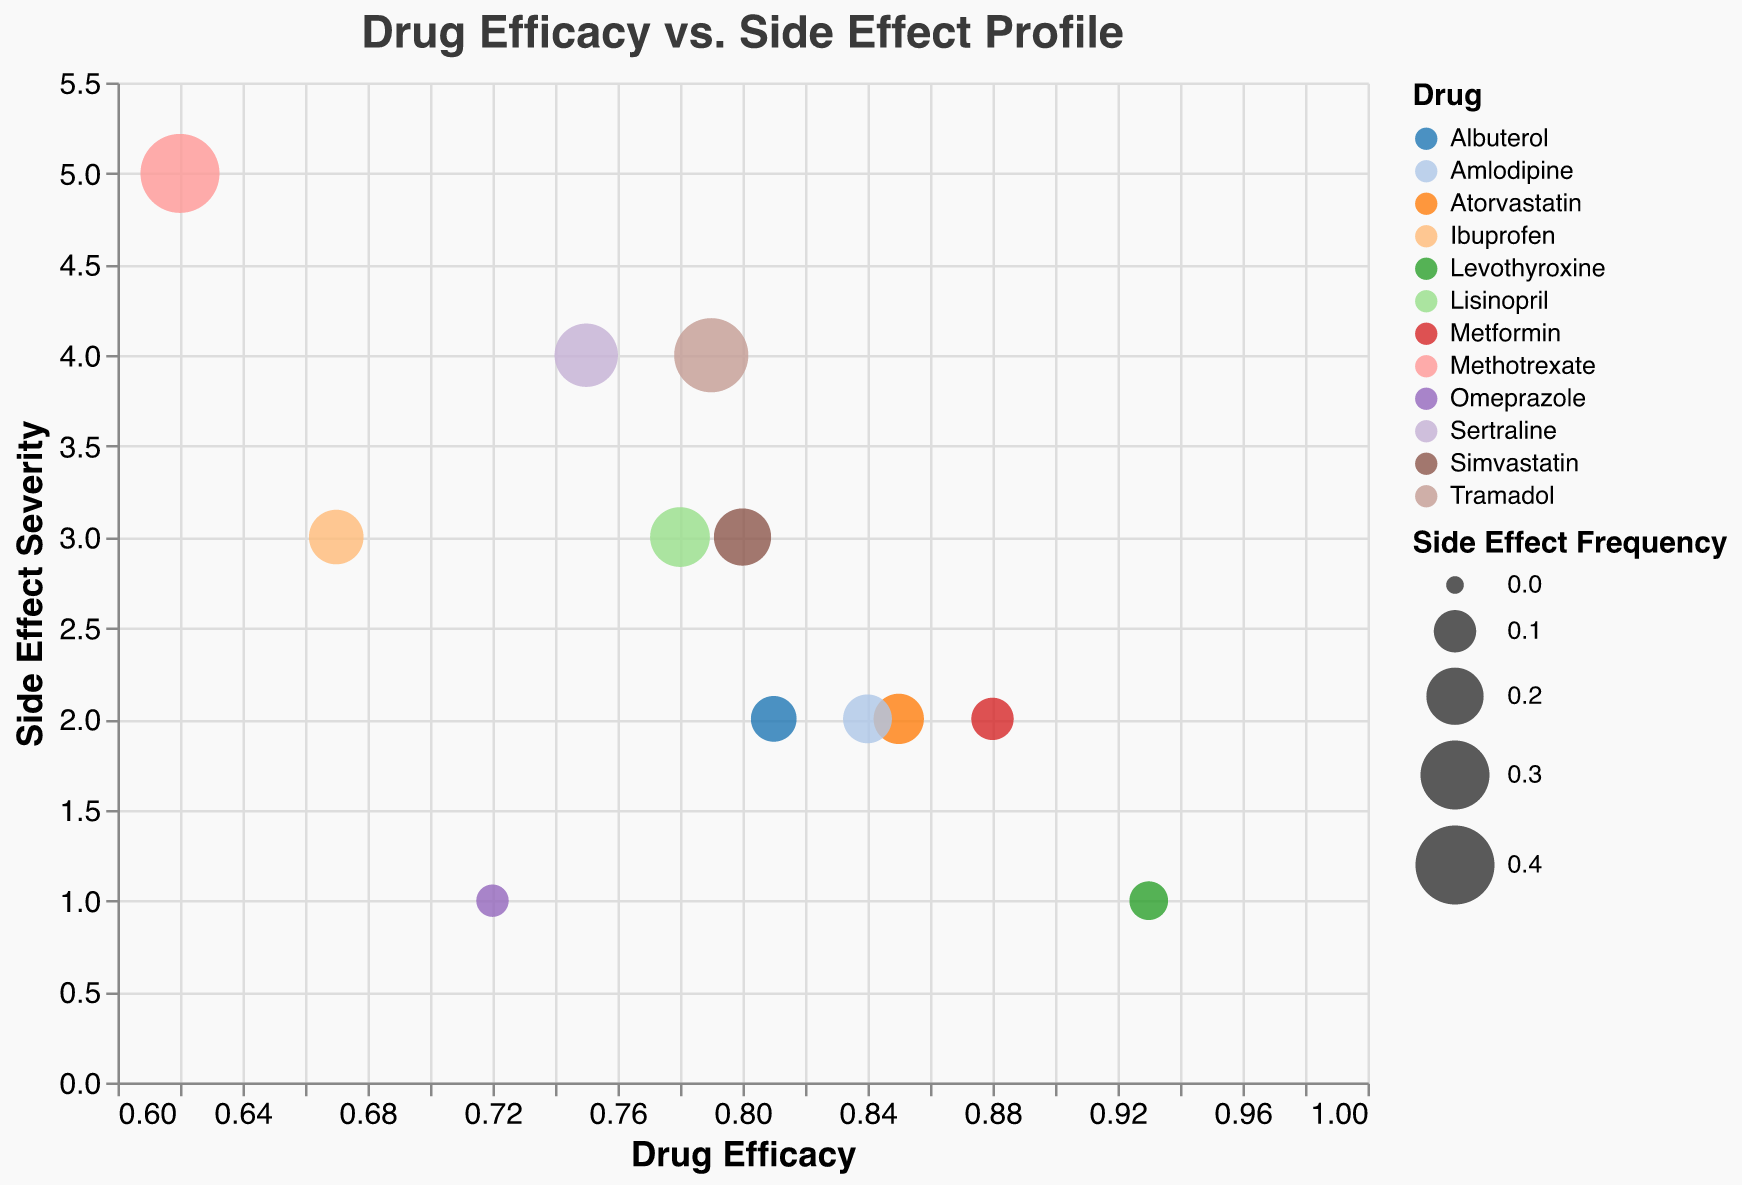What is the title of the figure? The figure's title is situated at the top, usually in a larger and bold font, making it easily noticeable. It states "Drug Efficacy vs. Side Effect Profile".
Answer: Drug Efficacy vs. Side Effect Profile Which drug has the highest efficacy? To determine the highest efficacy, look at the x-axis and identify the point furthest to the right. The tooltip or color legend can help identify the drug name. The point for Levothyroxine at 0.93 is farthest to the right.
Answer: Levothyroxine What is the side effect frequency of Methotrexate? Find Methotrexate in the color legend or the tooltip when hovering near its point. The size of the bubble representing Methotrexate indicates frequency. The tooltip shows a side effect frequency of 0.40.
Answer: 0.40 Which drug has the highest side effect severity? Examine the y-axis to find the point that is positioned highest. Methotrexate, with a value of 5, is the highest.
Answer: Methotrexate Comparing Metformin and Ibuprofen, which drug has a lower side effect frequency, and by how much? Locate Metformin and Ibuprofen on the plot or legend. Hover over or reference the tooltip for their side effect frequencies. Metformin has a frequency of 0.10, and Ibuprofen has 0.18. The difference is 0.18 - 0.10 = 0.08.
Answer: Metformin, by 0.08 Which drug(s) fall into the category of having side effect severity 2? Identify bubbles at y=2. Use the tooltip or legend to find the drugs. Atorvastatin, Metformin, Albuterol, and Amlodipine have side effect severity 2.
Answer: Atorvastatin, Metformin, Albuterol, Amlodipine Which drug has the largest bubble size on the plot? The bubble size correlates to side effect frequency. The largest bubble visually stands out and can be verified by the tooltip. Tramadol and Methotrexate have notably large bubbles, with Methotrexate slightly larger due to a frequency of 0.40.
Answer: Methotrexate What is the relationship between drug efficacy and side effect severity? Review the overall distribution of the points. There appears to be an inverse relationship, where higher efficacy tends to align with lower side effect severities.
Answer: Inverse relationship What's the average efficacy of drugs with a side effect severity of 3? Identify all drugs with y=3: Lisinopril, Ibuprofen, and Simvastatin. Calculate their mean efficacy: (0.78 + 0.67 + 0.80) / 3 = 2.25 / 3 = 0.75.
Answer: 0.75 Which drug has a lower efficacy than 0.80 but higher severity than 2? Focus on drugs where the x-value is < 0.80 and y-value > 2. Review potential candidates, and identify Sertraline (efficacy 0.75, severity 4) and Tramadol (efficacy 0.79, severity 4). Both meet the criteria.
Answer: Sertraline, Tramadol 